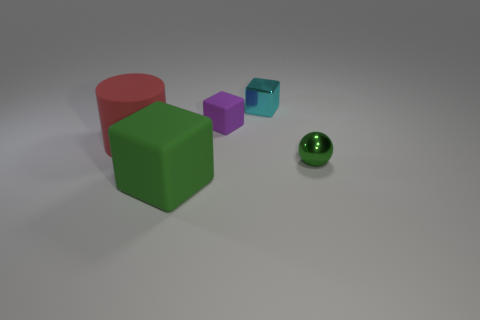Add 4 large green blocks. How many objects exist? 9 Subtract all blocks. How many objects are left? 2 Subtract 0 green cylinders. How many objects are left? 5 Subtract all red cylinders. Subtract all rubber things. How many objects are left? 1 Add 2 cyan things. How many cyan things are left? 3 Add 2 purple metal cubes. How many purple metal cubes exist? 2 